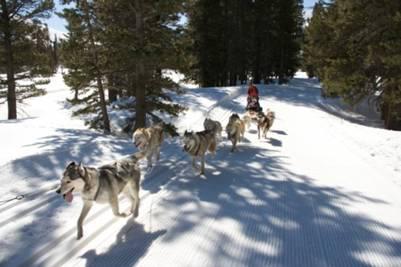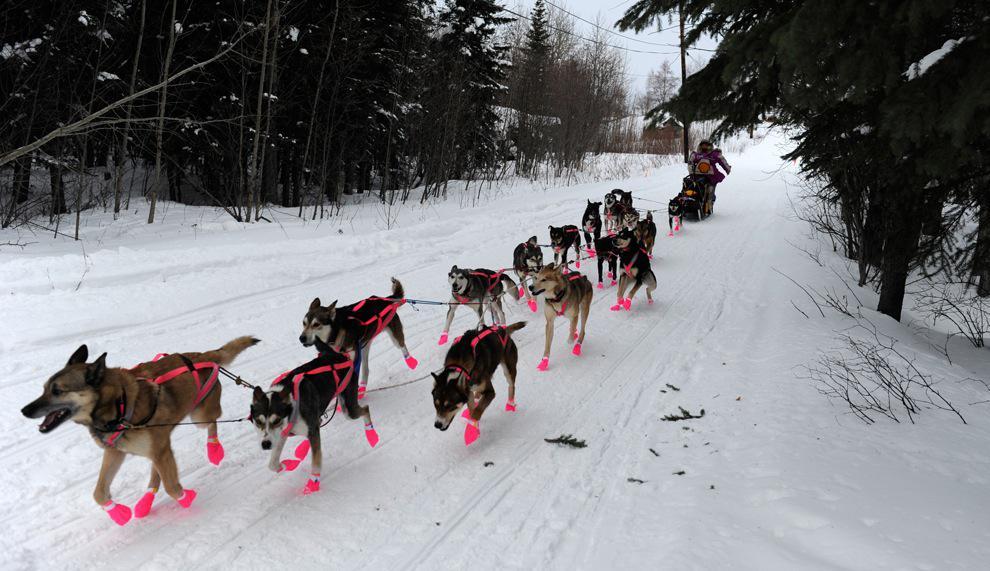The first image is the image on the left, the second image is the image on the right. Evaluate the accuracy of this statement regarding the images: "An image shows a team of sled dogs wearing matching booties.". Is it true? Answer yes or no. Yes. The first image is the image on the left, the second image is the image on the right. Evaluate the accuracy of this statement regarding the images: "There are at least three humans in the right image.". Is it true? Answer yes or no. No. 